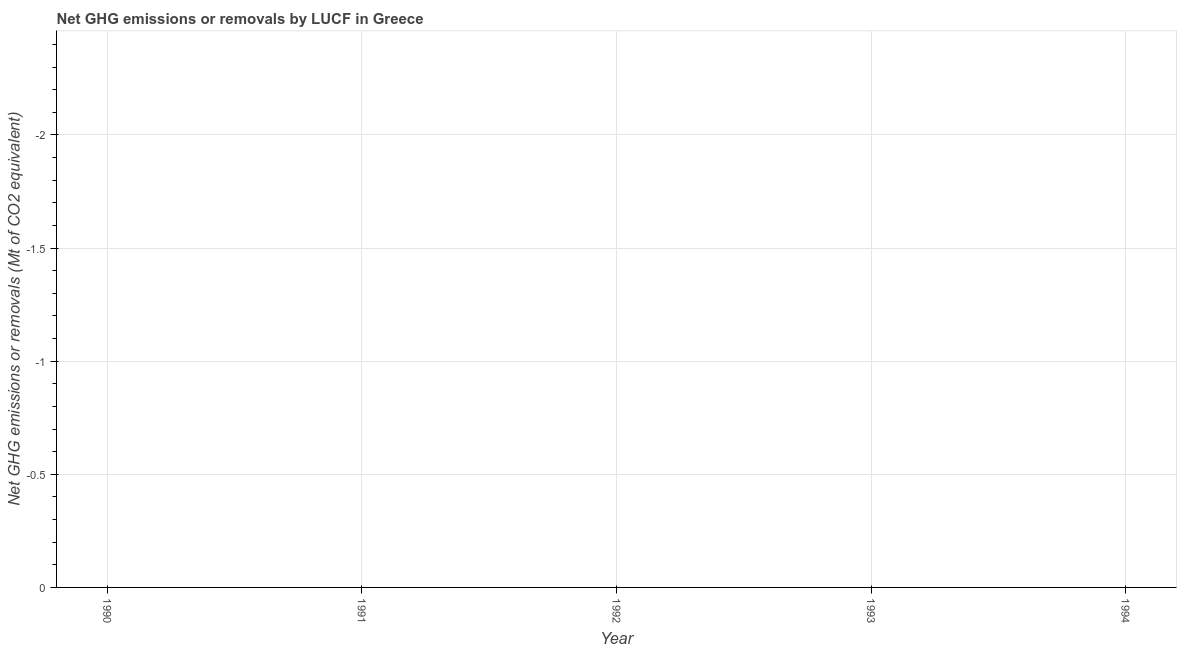What is the ghg net emissions or removals in 1992?
Your answer should be compact. 0. What is the average ghg net emissions or removals per year?
Your answer should be compact. 0. How many years are there in the graph?
Offer a very short reply. 5. Are the values on the major ticks of Y-axis written in scientific E-notation?
Provide a short and direct response. No. What is the title of the graph?
Ensure brevity in your answer.  Net GHG emissions or removals by LUCF in Greece. What is the label or title of the Y-axis?
Your response must be concise. Net GHG emissions or removals (Mt of CO2 equivalent). What is the Net GHG emissions or removals (Mt of CO2 equivalent) in 1990?
Your response must be concise. 0. What is the Net GHG emissions or removals (Mt of CO2 equivalent) in 1991?
Give a very brief answer. 0. What is the Net GHG emissions or removals (Mt of CO2 equivalent) in 1992?
Your answer should be very brief. 0. 